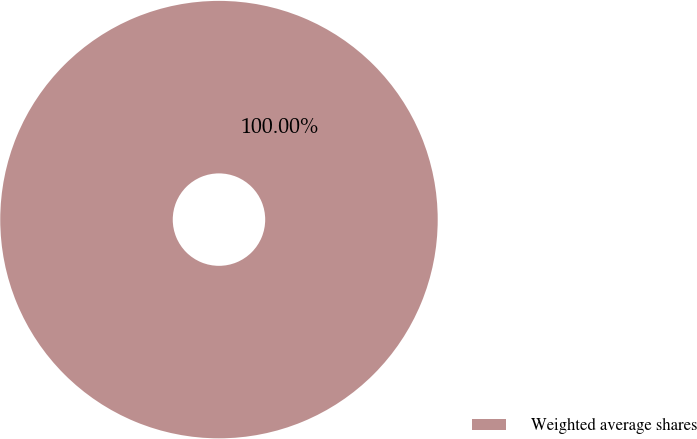<chart> <loc_0><loc_0><loc_500><loc_500><pie_chart><fcel>Weighted average shares<nl><fcel>100.0%<nl></chart> 